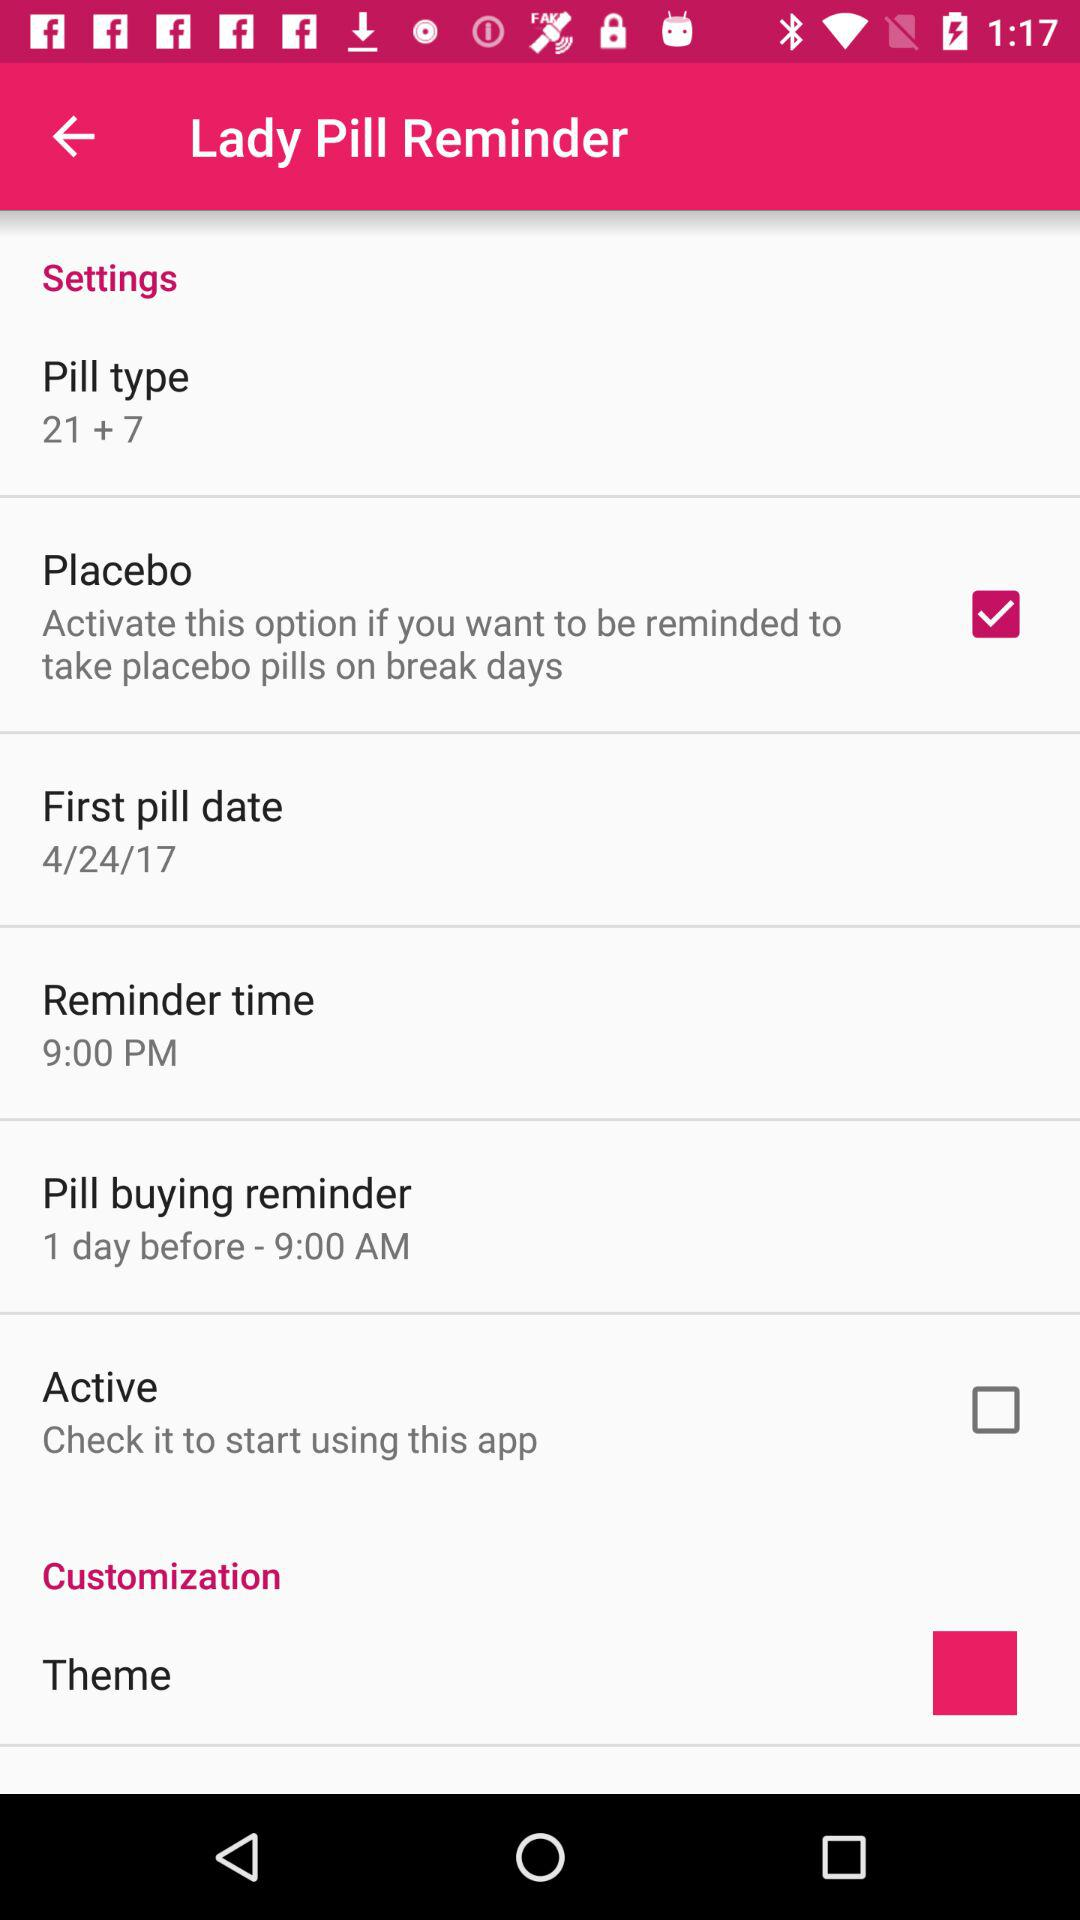What is the first pill date? The first pill date is April 24, 2017. 